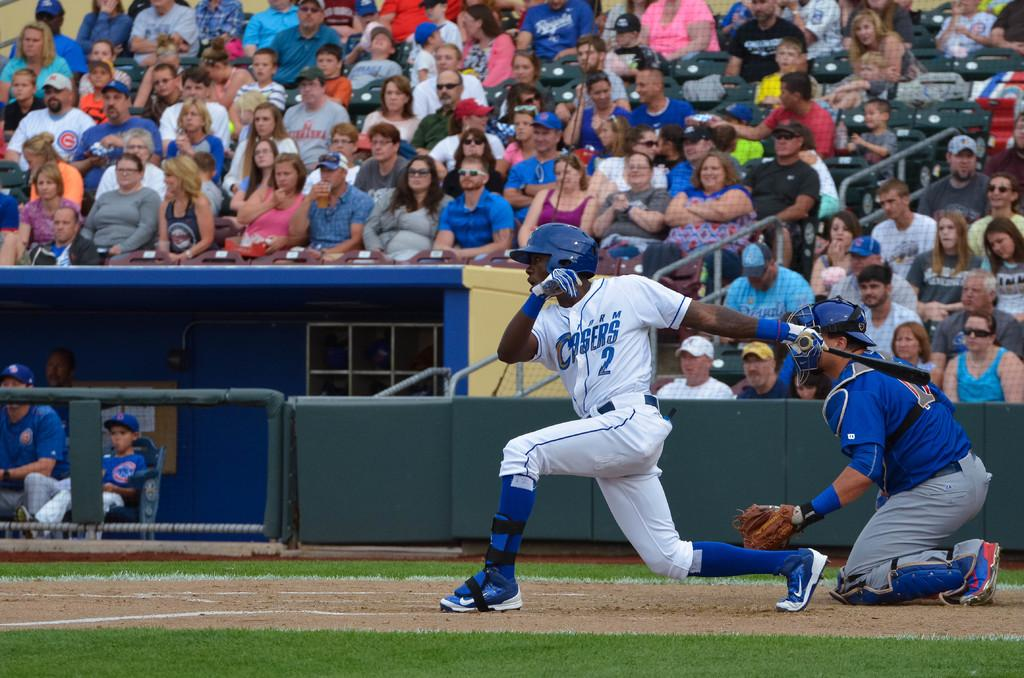What type of location is depicted in the image? The image is of a stadium. Are there any people present in the image? Yes, there are people in the image. What are some of the activities the people are engaged in? Some people are sitting, while others are playing on the ground. What type of bun is being used as an apparatus for the people playing on the ground? There is no bun or apparatus present in the image; people are simply playing on the ground. 